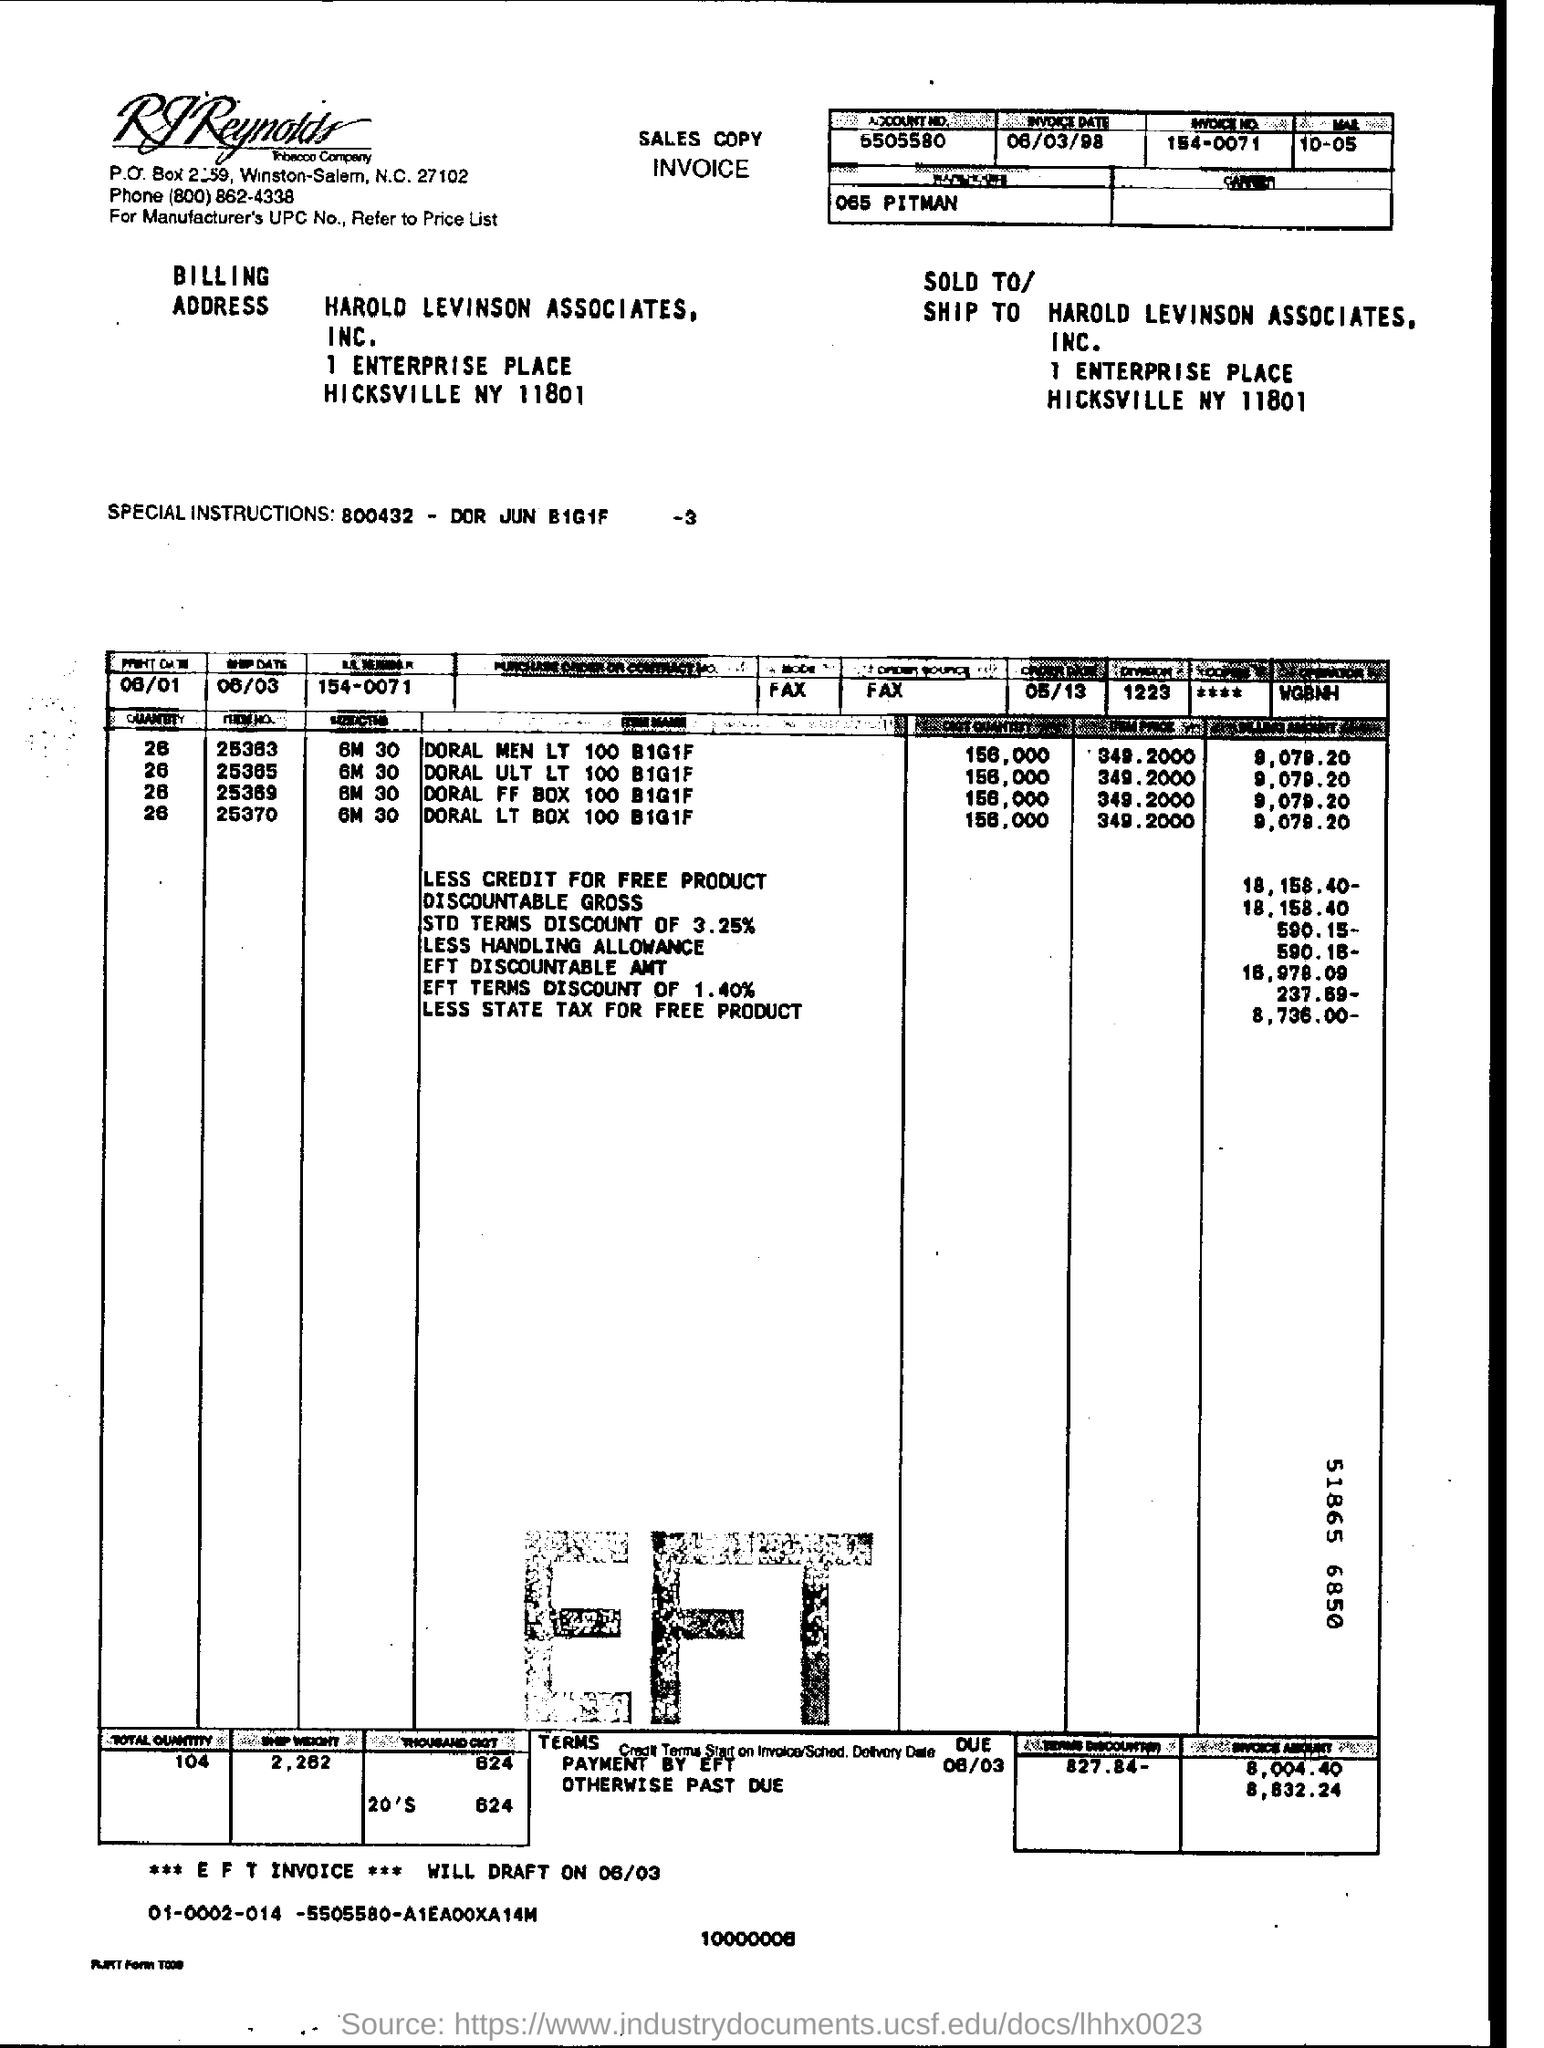What are the special instructions noted on this invoice? The special instructions noted on the invoice are '800432 - DOR JUN B161F -3'. This likely pertains to a special code or reference for the billing system or a specific order detail. 